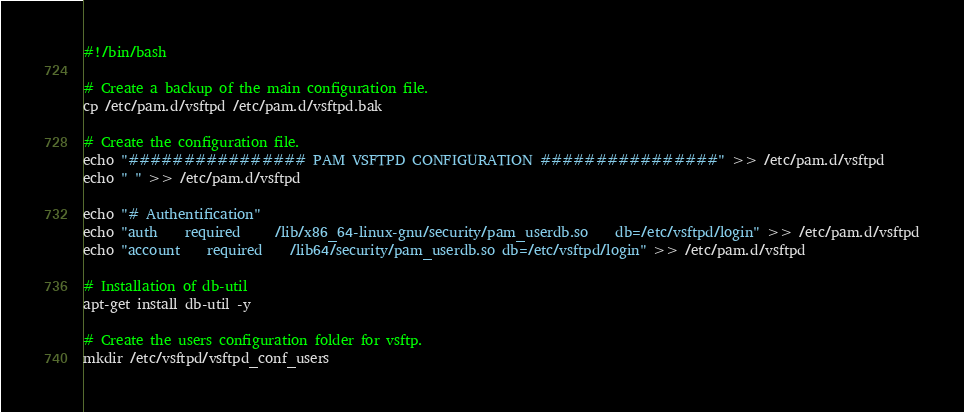<code> <loc_0><loc_0><loc_500><loc_500><_Bash_>#!/bin/bash

# Create a backup of the main configuration file.
cp /etc/pam.d/vsftpd /etc/pam.d/vsftpd.bak

# Create the configuration file.
echo "################ PAM VSFTPD CONFIGURATION ################" >> /etc/pam.d/vsftpd
echo " " >> /etc/pam.d/vsftpd

echo "# Authentification"
echo "auth    required     /lib/x86_64-linux-gnu/security/pam_userdb.so    db=/etc/vsftpd/login" >> /etc/pam.d/vsftpd
echo "account    required    /lib64/security/pam_userdb.so db=/etc/vsftpd/login" >> /etc/pam.d/vsftpd

# Installation of db-util
apt-get install db-util -y

# Create the users configuration folder for vsftp.
mkdir /etc/vsftpd/vsftpd_conf_users
</code> 